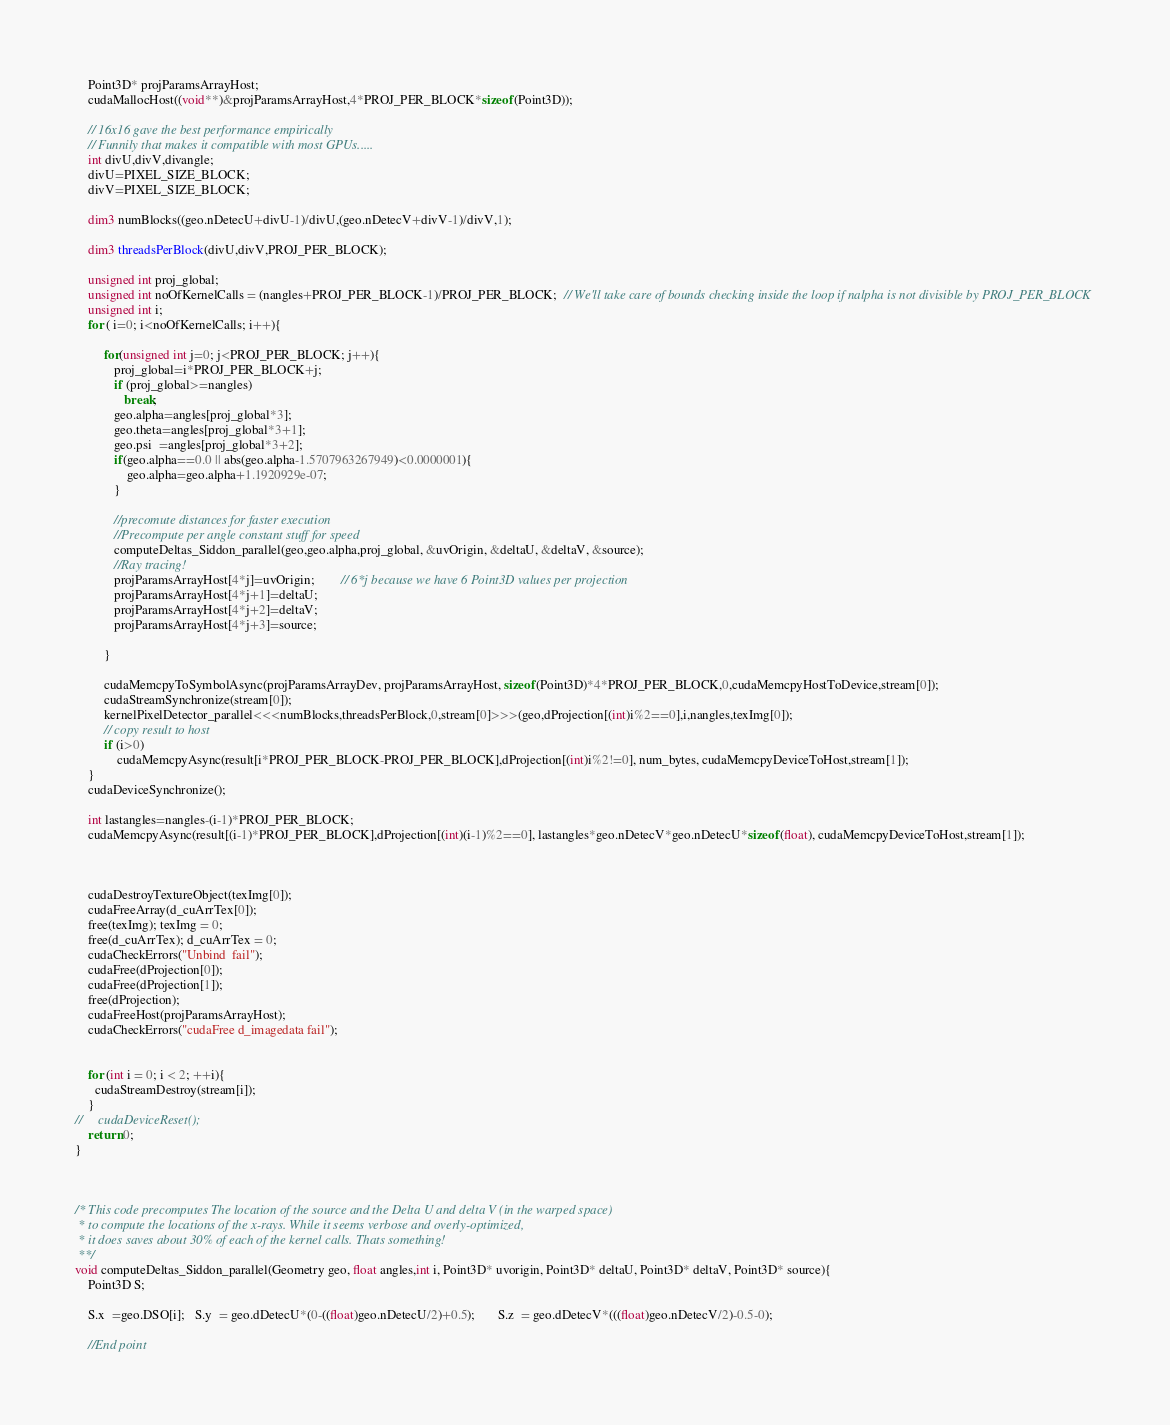Convert code to text. <code><loc_0><loc_0><loc_500><loc_500><_Cuda_>    Point3D* projParamsArrayHost;
    cudaMallocHost((void**)&projParamsArrayHost,4*PROJ_PER_BLOCK*sizeof(Point3D));

    // 16x16 gave the best performance empirically
    // Funnily that makes it compatible with most GPUs.....
    int divU,divV,divangle;
    divU=PIXEL_SIZE_BLOCK;
    divV=PIXEL_SIZE_BLOCK;
    
    dim3 numBlocks((geo.nDetecU+divU-1)/divU,(geo.nDetecV+divV-1)/divV,1);
    
    dim3 threadsPerBlock(divU,divV,PROJ_PER_BLOCK);
    
    unsigned int proj_global;
    unsigned int noOfKernelCalls = (nangles+PROJ_PER_BLOCK-1)/PROJ_PER_BLOCK;  // We'll take care of bounds checking inside the loop if nalpha is not divisible by PROJ_PER_BLOCK
    unsigned int i;
    for ( i=0; i<noOfKernelCalls; i++){
        
         for(unsigned int j=0; j<PROJ_PER_BLOCK; j++){
            proj_global=i*PROJ_PER_BLOCK+j;
            if (proj_global>=nangles)
               break;
            geo.alpha=angles[proj_global*3];
            geo.theta=angles[proj_global*3+1];
            geo.psi  =angles[proj_global*3+2];
            if(geo.alpha==0.0 || abs(geo.alpha-1.5707963267949)<0.0000001){
                geo.alpha=geo.alpha+1.1920929e-07;
            }
            
            //precomute distances for faster execution
            //Precompute per angle constant stuff for speed
            computeDeltas_Siddon_parallel(geo,geo.alpha,proj_global, &uvOrigin, &deltaU, &deltaV, &source);
            //Ray tracing!
            projParamsArrayHost[4*j]=uvOrigin;		// 6*j because we have 6 Point3D values per projection
            projParamsArrayHost[4*j+1]=deltaU;
            projParamsArrayHost[4*j+2]=deltaV;
            projParamsArrayHost[4*j+3]=source;

         }
         
         cudaMemcpyToSymbolAsync(projParamsArrayDev, projParamsArrayHost, sizeof(Point3D)*4*PROJ_PER_BLOCK,0,cudaMemcpyHostToDevice,stream[0]);
         cudaStreamSynchronize(stream[0]);
         kernelPixelDetector_parallel<<<numBlocks,threadsPerBlock,0,stream[0]>>>(geo,dProjection[(int)i%2==0],i,nangles,texImg[0]);
         // copy result to host
         if (i>0)
             cudaMemcpyAsync(result[i*PROJ_PER_BLOCK-PROJ_PER_BLOCK],dProjection[(int)i%2!=0], num_bytes, cudaMemcpyDeviceToHost,stream[1]);
    }
    cudaDeviceSynchronize();
    
    int lastangles=nangles-(i-1)*PROJ_PER_BLOCK;
    cudaMemcpyAsync(result[(i-1)*PROJ_PER_BLOCK],dProjection[(int)(i-1)%2==0], lastangles*geo.nDetecV*geo.nDetecU*sizeof(float), cudaMemcpyDeviceToHost,stream[1]);

    

    cudaDestroyTextureObject(texImg[0]);
    cudaFreeArray(d_cuArrTex[0]);
    free(texImg); texImg = 0;
    free(d_cuArrTex); d_cuArrTex = 0;
    cudaCheckErrors("Unbind  fail");
    cudaFree(dProjection[0]);
    cudaFree(dProjection[1]);
    free(dProjection);
    cudaFreeHost(projParamsArrayHost);
    cudaCheckErrors("cudaFree d_imagedata fail");
    
    
    for (int i = 0; i < 2; ++i){
      cudaStreamDestroy(stream[i]);
    }
//     cudaDeviceReset();
    return 0;
}



/* This code precomputes The location of the source and the Delta U and delta V (in the warped space)
 * to compute the locations of the x-rays. While it seems verbose and overly-optimized,
 * it does saves about 30% of each of the kernel calls. Thats something!
 **/
void computeDeltas_Siddon_parallel(Geometry geo, float angles,int i, Point3D* uvorigin, Point3D* deltaU, Point3D* deltaV, Point3D* source){
    Point3D S;
    
    S.x  =geo.DSO[i];   S.y  = geo.dDetecU*(0-((float)geo.nDetecU/2)+0.5);       S.z  = geo.dDetecV*(((float)geo.nDetecV/2)-0.5-0);
    
    //End point</code> 